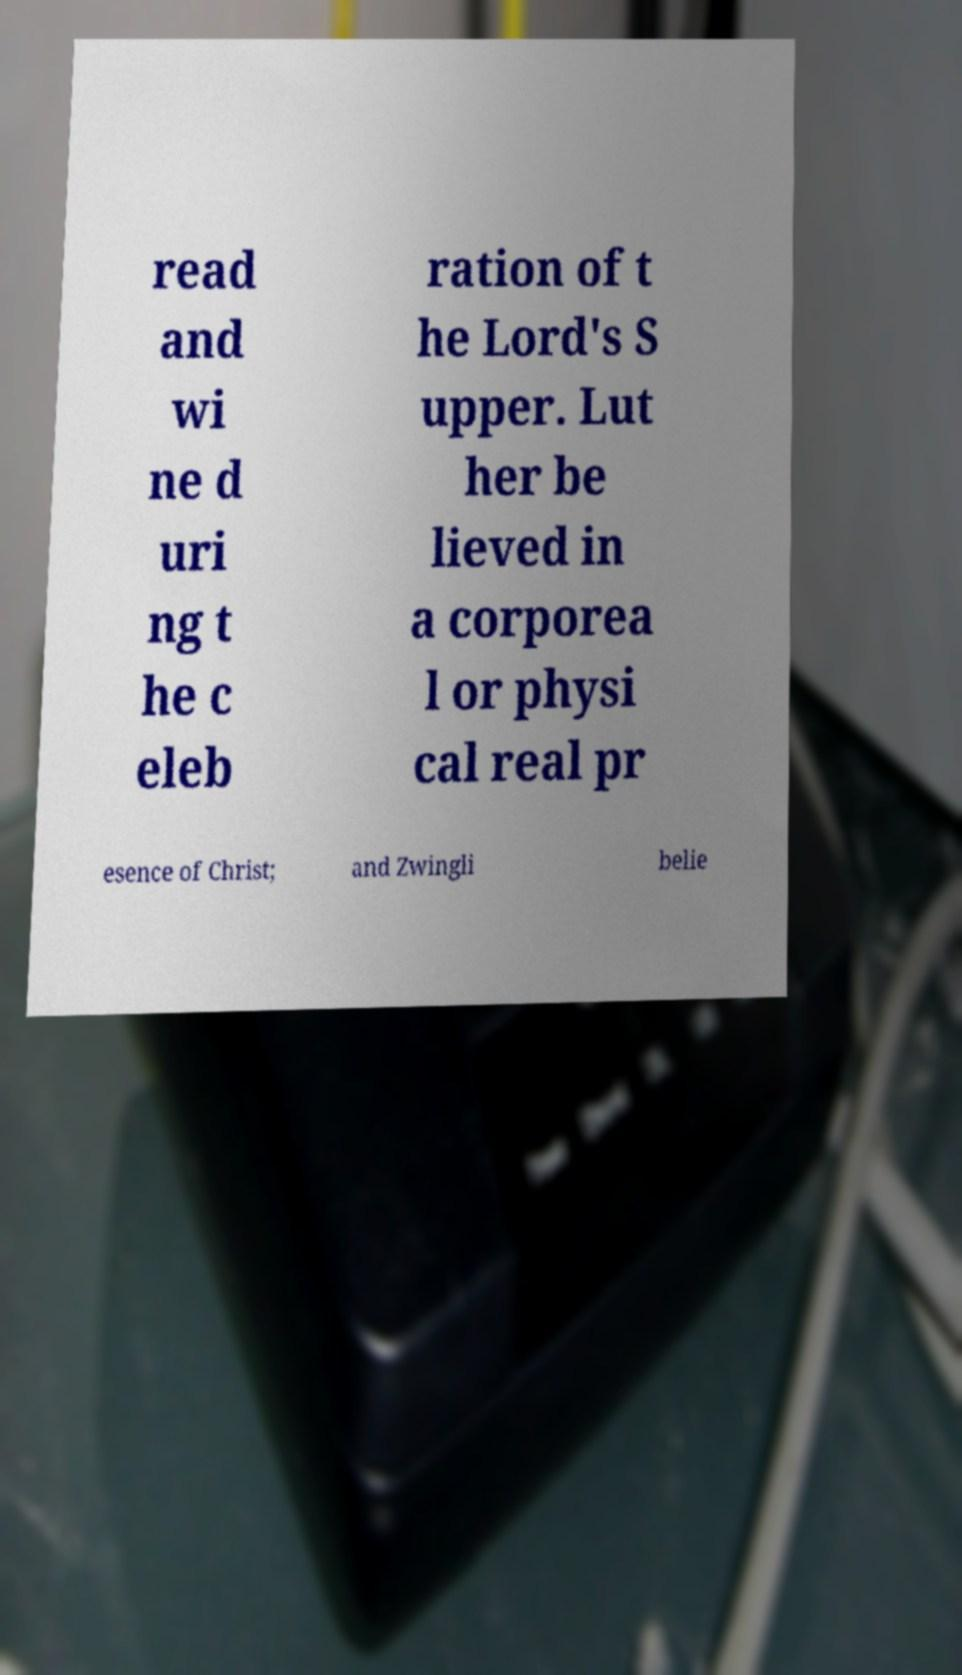Please identify and transcribe the text found in this image. read and wi ne d uri ng t he c eleb ration of t he Lord's S upper. Lut her be lieved in a corporea l or physi cal real pr esence of Christ; and Zwingli belie 